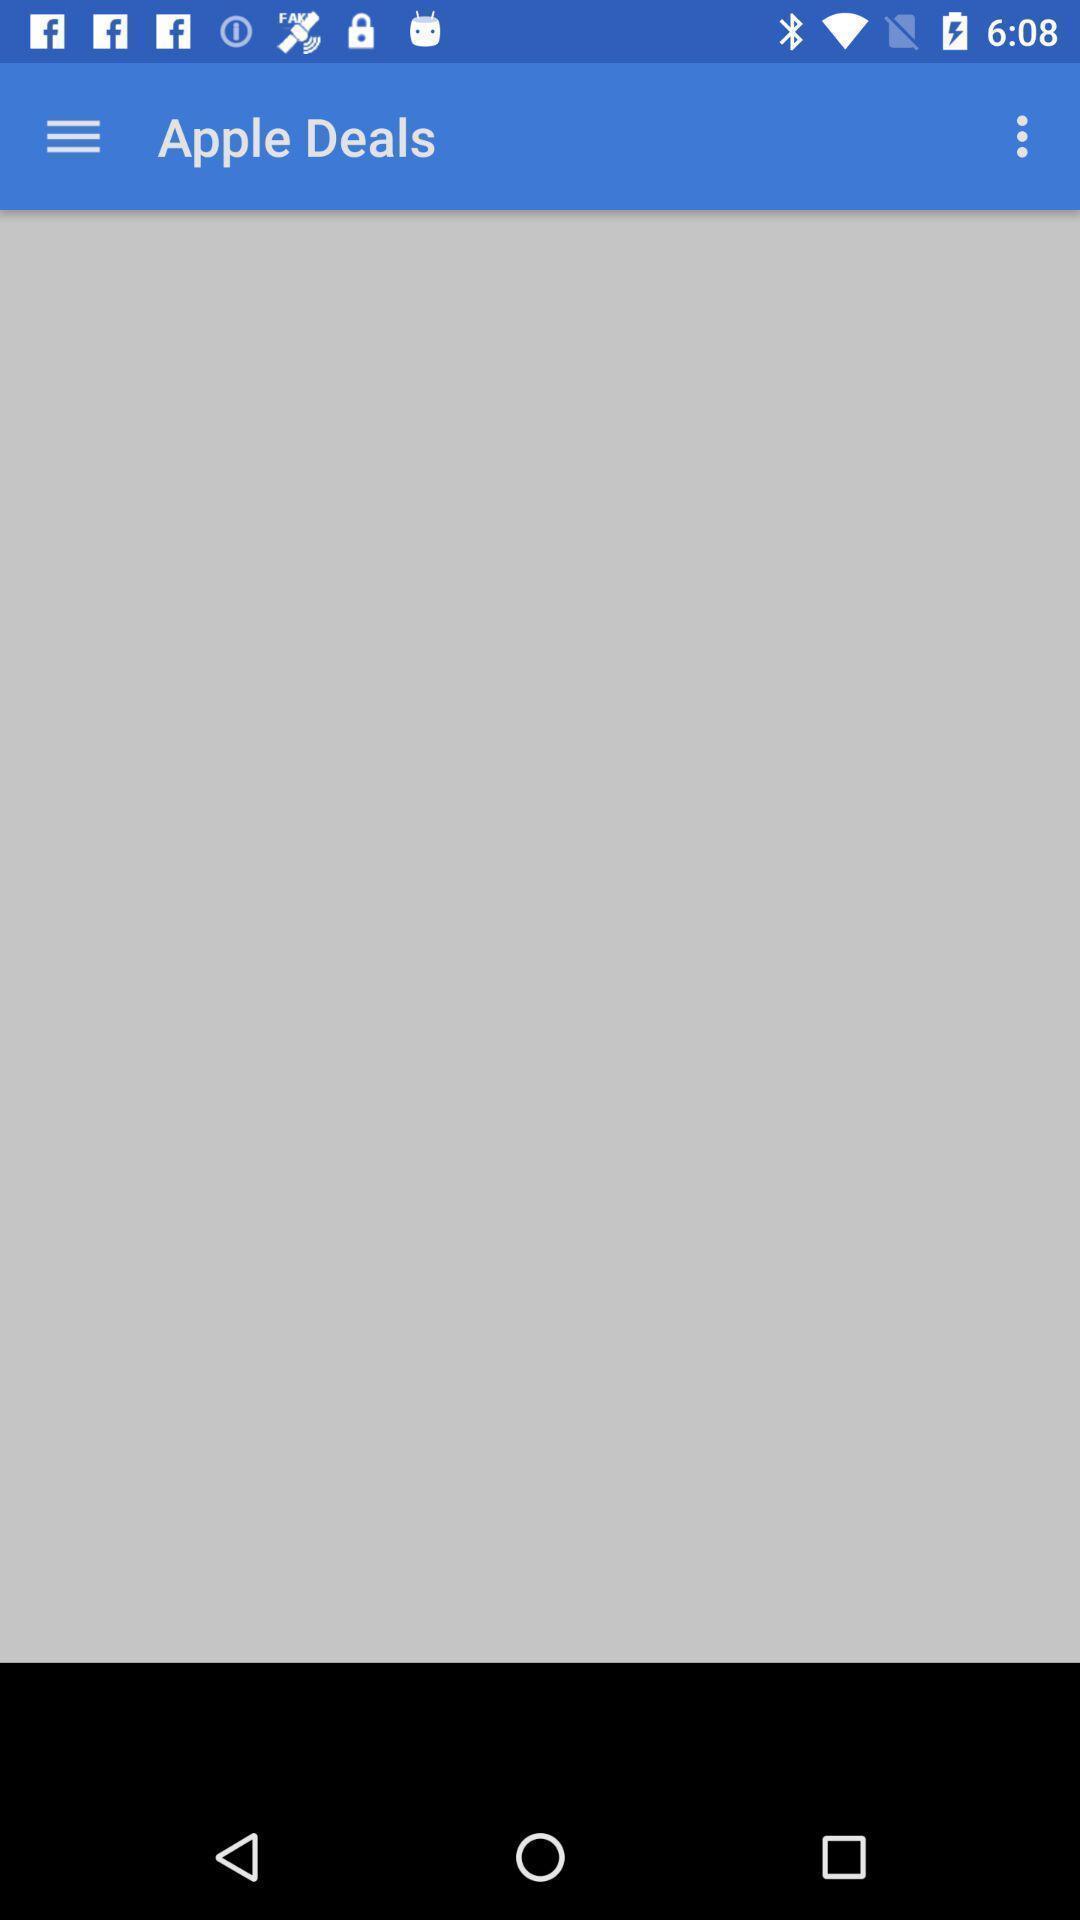Summarize the main components in this picture. Screen shows apple deals page. 